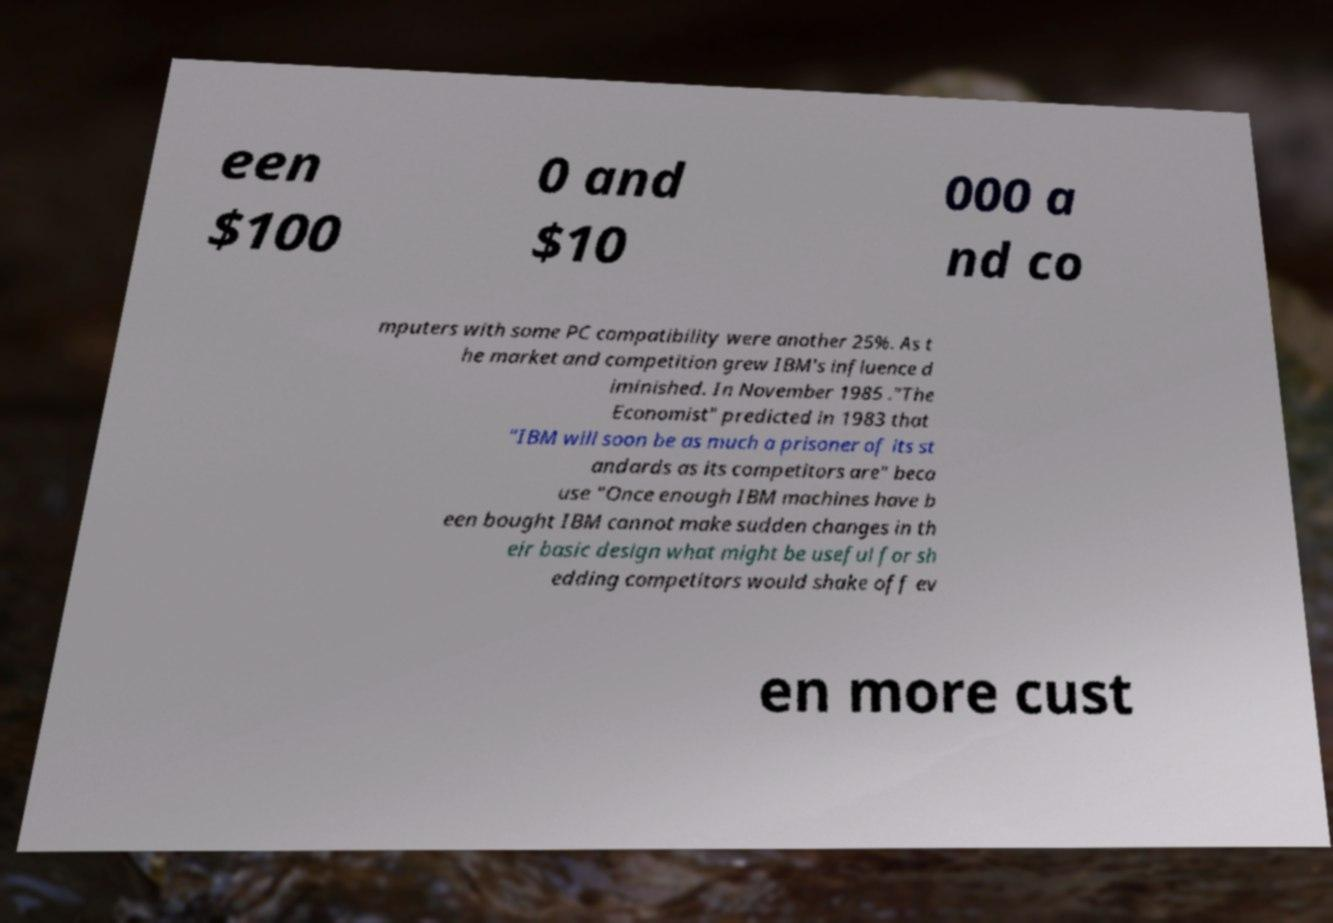Could you assist in decoding the text presented in this image and type it out clearly? een $100 0 and $10 000 a nd co mputers with some PC compatibility were another 25%. As t he market and competition grew IBM's influence d iminished. In November 1985 ."The Economist" predicted in 1983 that "IBM will soon be as much a prisoner of its st andards as its competitors are" beca use "Once enough IBM machines have b een bought IBM cannot make sudden changes in th eir basic design what might be useful for sh edding competitors would shake off ev en more cust 